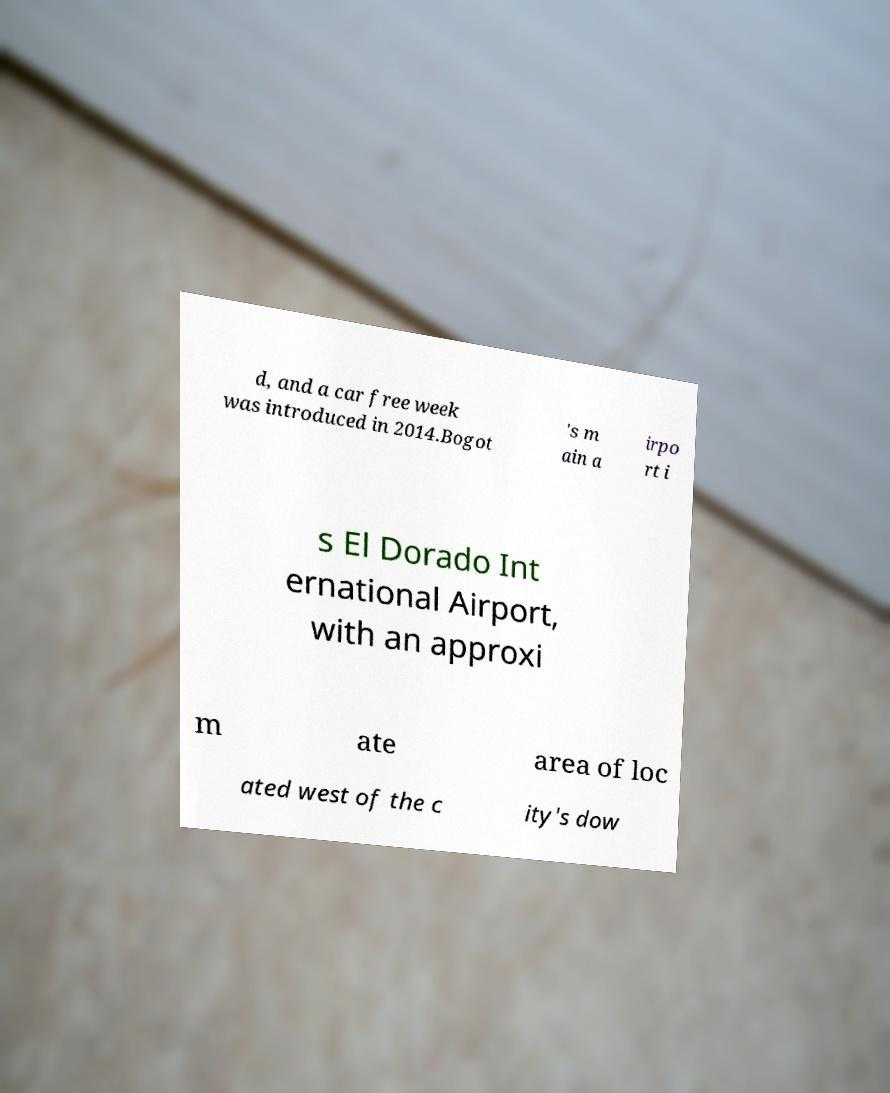Can you accurately transcribe the text from the provided image for me? d, and a car free week was introduced in 2014.Bogot 's m ain a irpo rt i s El Dorado Int ernational Airport, with an approxi m ate area of loc ated west of the c ity's dow 